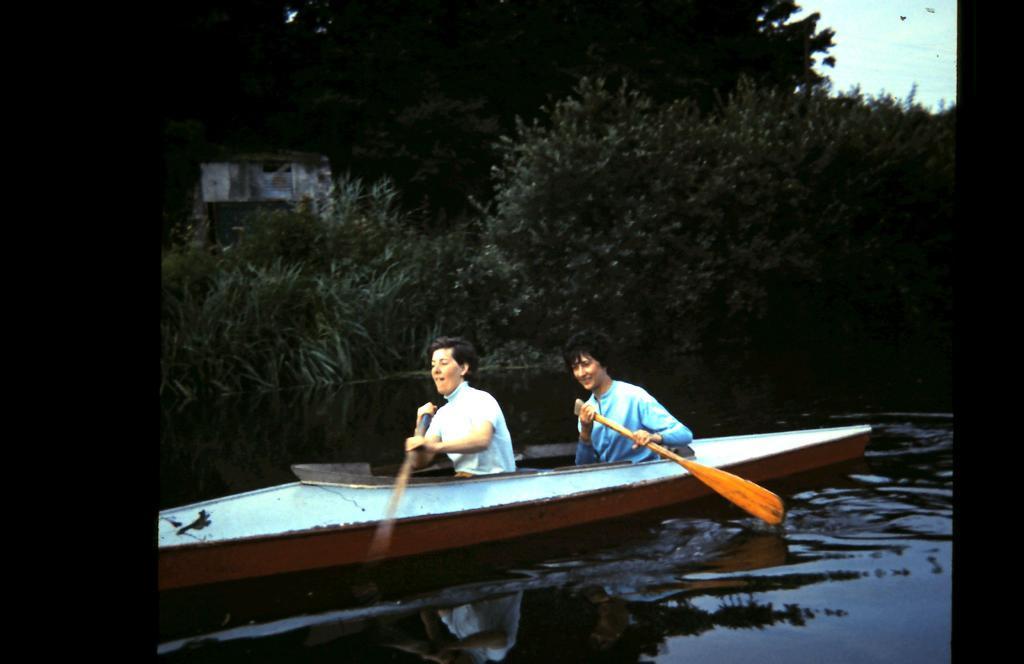Can you describe this image briefly? This picture shows couple of them riding a boat in the water and we see few trees and a blue cloudy sky. 